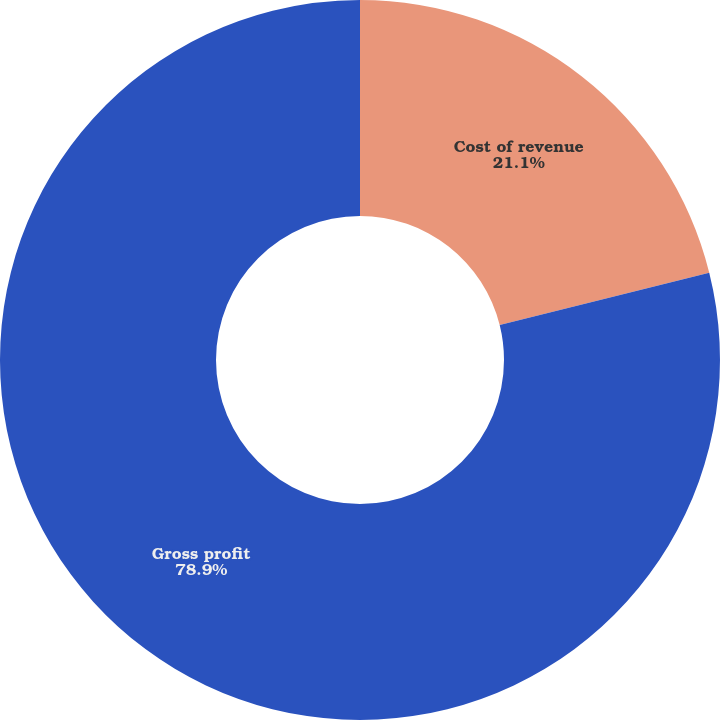Convert chart. <chart><loc_0><loc_0><loc_500><loc_500><pie_chart><fcel>Cost of revenue<fcel>Gross profit<nl><fcel>21.1%<fcel>78.9%<nl></chart> 